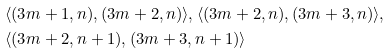<formula> <loc_0><loc_0><loc_500><loc_500>& \langle ( 3 m + 1 , n ) , ( 3 m + 2 , n ) \rangle , \langle ( 3 m + 2 , n ) , ( 3 m + 3 , n ) \rangle , \\ & \langle ( 3 m + 2 , n + 1 ) , ( 3 m + 3 , n + 1 ) \rangle</formula> 